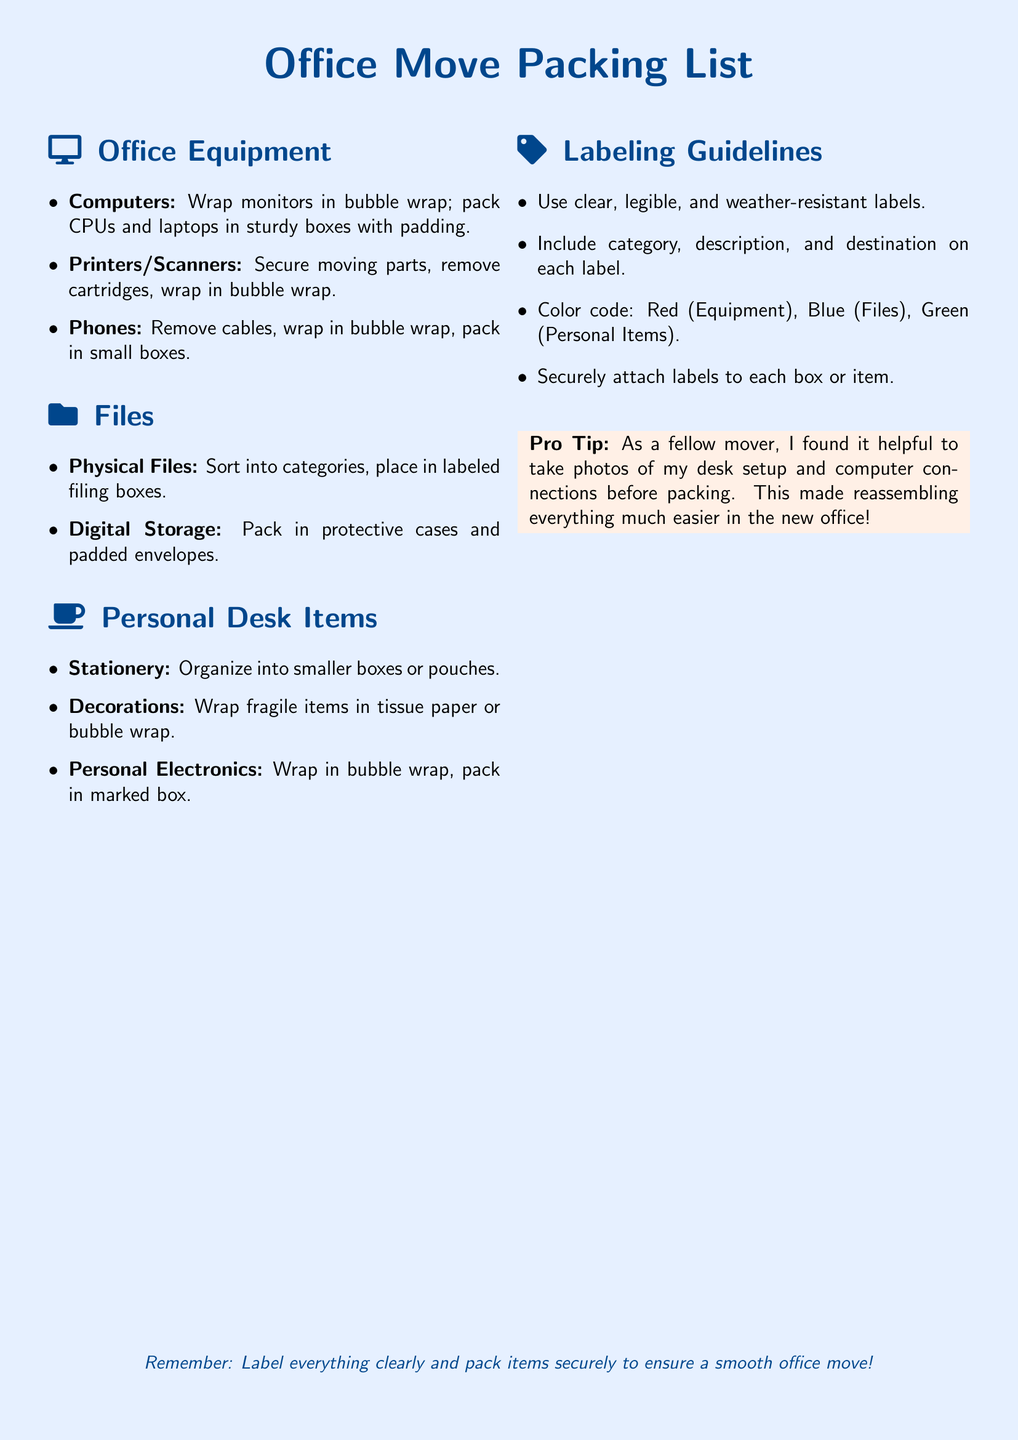What is the title of the document? The title of the document is indicated at the top of the rendered page.
Answer: Office Move Packing List How many categories are listed under Office Equipment? The categories under Office Equipment can be counted from the document's sections.
Answer: Three What color represents Files in the labeling guidelines? The color coding for Files is mentioned within the labeling guidelines.
Answer: Blue What should be done to monitors before packing? The step for packing monitors is specified in the Office Equipment section.
Answer: Wrap in bubble wrap What additional item is suggested to pack personal electronics in? The packing suggestion for personal electronics is detailed under Personal Desk Items.
Answer: Marked box What should labels include according to the guidelines? The guidelines provide a list of what to include on each label for clarity.
Answer: Category, description, and destination What item is wrapped in tissue paper? The document specifies which item should be wrapped in tissue paper under Personal Desk Items.
Answer: Decorations How is the advice in the "Pro Tip" section presented? The advice is highlighted in a specific style within the document.
Answer: As a helpful tip What is the recommended method for securing labels? The labeling guidelines give specific instructions on how to attach labels securely.
Answer: Securely attach labels to each box or item 